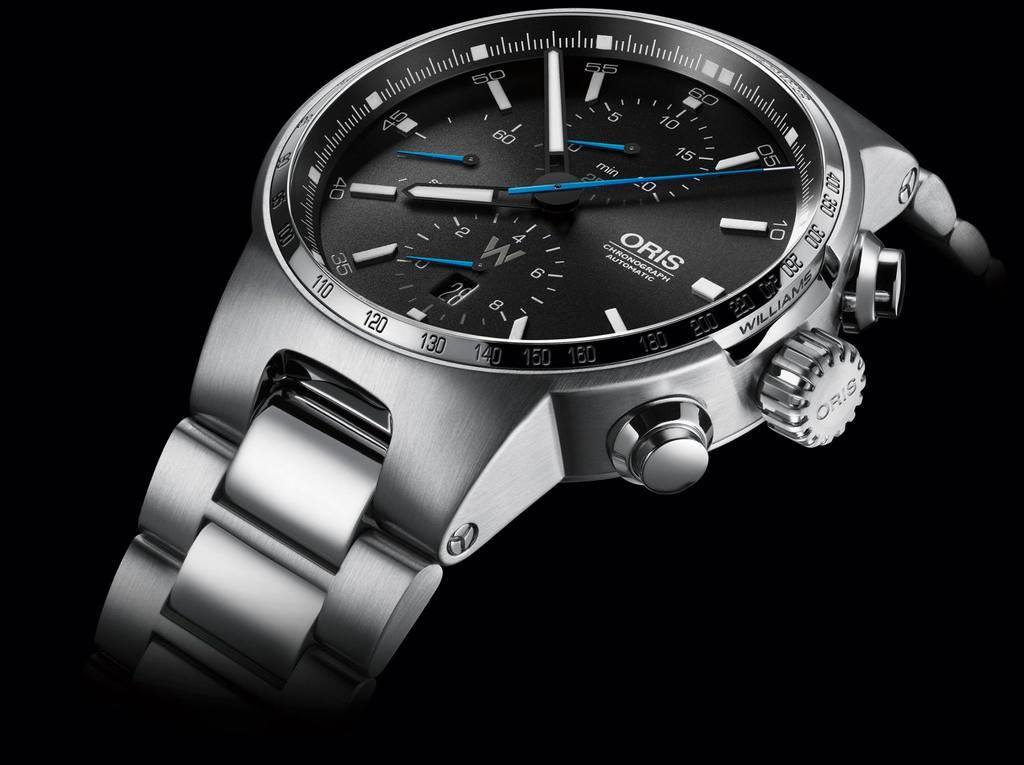Provide a one-sentence caption for the provided image. A close up high resolution view of an Oris wristwatch. 